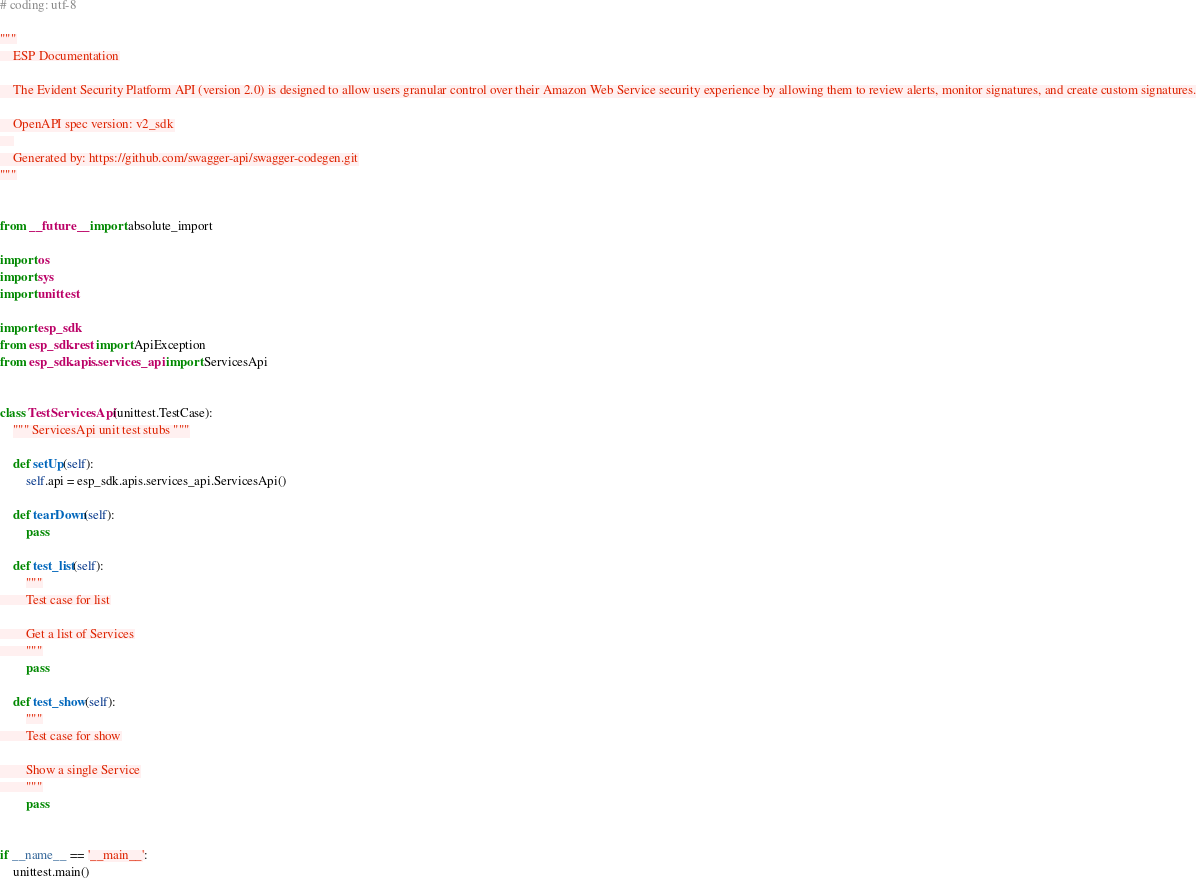Convert code to text. <code><loc_0><loc_0><loc_500><loc_500><_Python_># coding: utf-8

"""
    ESP Documentation

    The Evident Security Platform API (version 2.0) is designed to allow users granular control over their Amazon Web Service security experience by allowing them to review alerts, monitor signatures, and create custom signatures.

    OpenAPI spec version: v2_sdk
    
    Generated by: https://github.com/swagger-api/swagger-codegen.git
"""


from __future__ import absolute_import

import os
import sys
import unittest

import esp_sdk
from esp_sdk.rest import ApiException
from esp_sdk.apis.services_api import ServicesApi


class TestServicesApi(unittest.TestCase):
    """ ServicesApi unit test stubs """

    def setUp(self):
        self.api = esp_sdk.apis.services_api.ServicesApi()

    def tearDown(self):
        pass

    def test_list(self):
        """
        Test case for list

        Get a list of Services
        """
        pass

    def test_show(self):
        """
        Test case for show

        Show a single Service
        """
        pass


if __name__ == '__main__':
    unittest.main()
</code> 